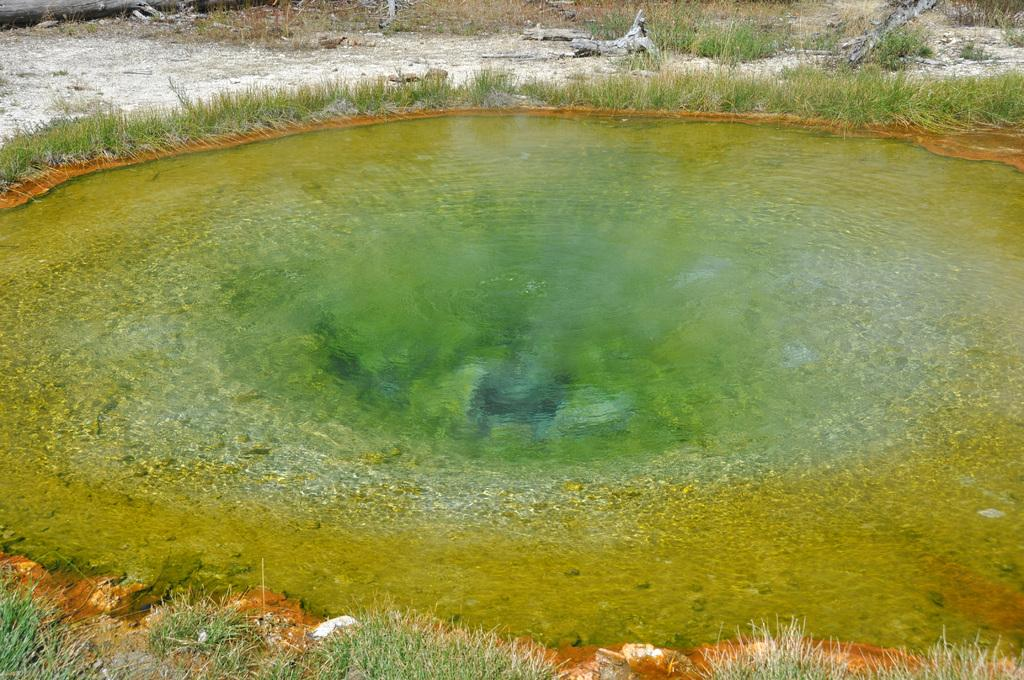What is one of the natural elements visible in the image? Water is visible in the image. What type of vegetation can be seen in the image? There is grass in the image. What material is present on the ground in the image? There is wood on the ground in the image. How many tickets can be seen on the floor in the image? There is no mention of tickets or a floor in the image; it features water, grass, and wood on the ground. 